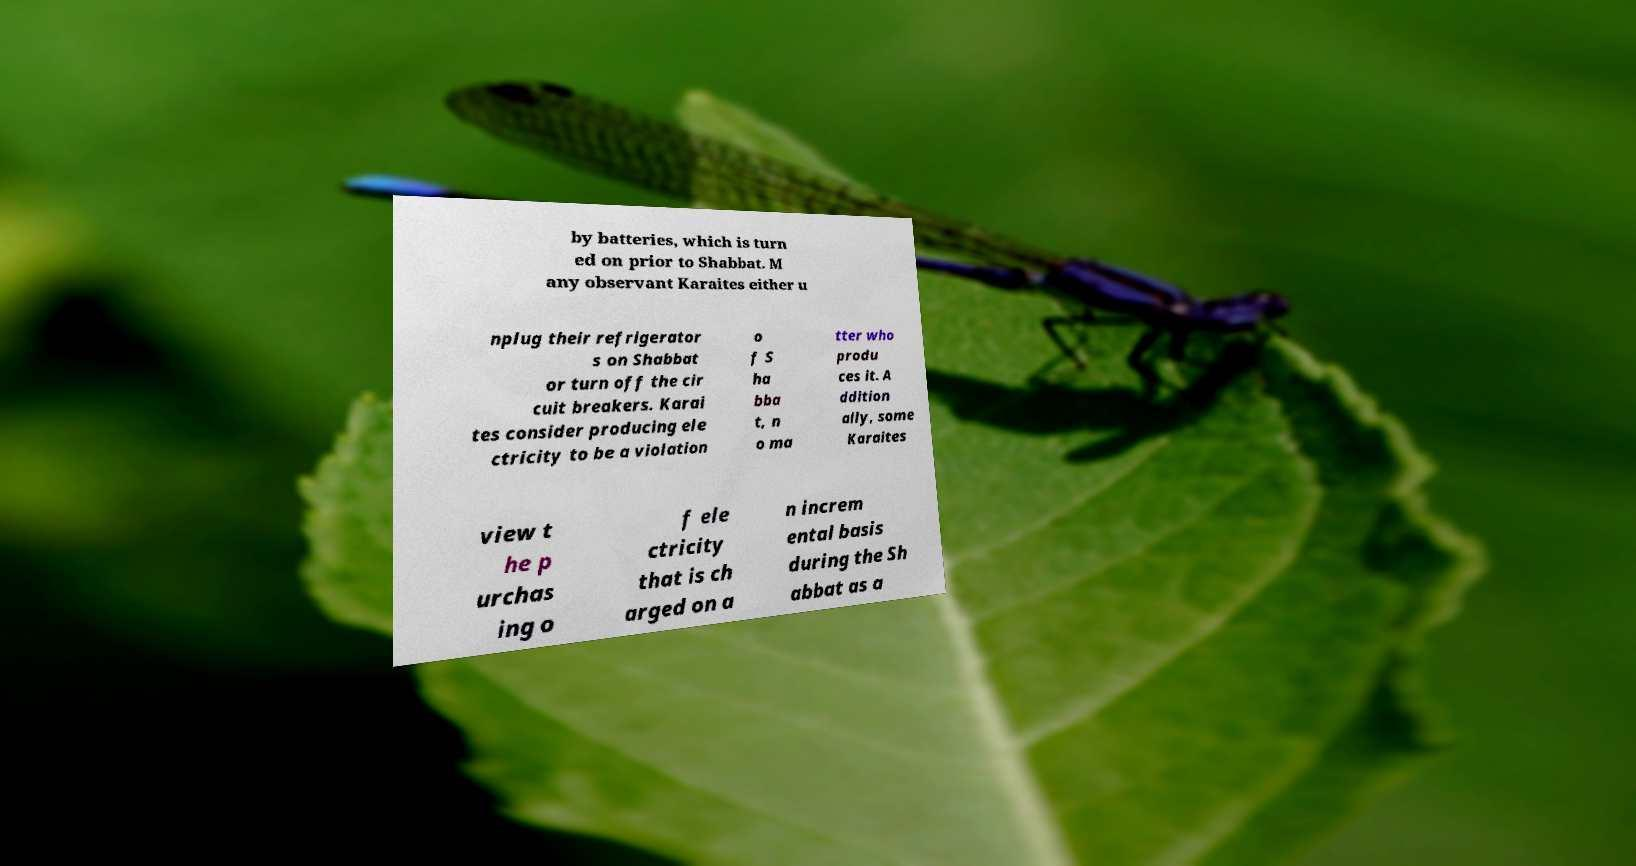For documentation purposes, I need the text within this image transcribed. Could you provide that? by batteries, which is turn ed on prior to Shabbat. M any observant Karaites either u nplug their refrigerator s on Shabbat or turn off the cir cuit breakers. Karai tes consider producing ele ctricity to be a violation o f S ha bba t, n o ma tter who produ ces it. A ddition ally, some Karaites view t he p urchas ing o f ele ctricity that is ch arged on a n increm ental basis during the Sh abbat as a 